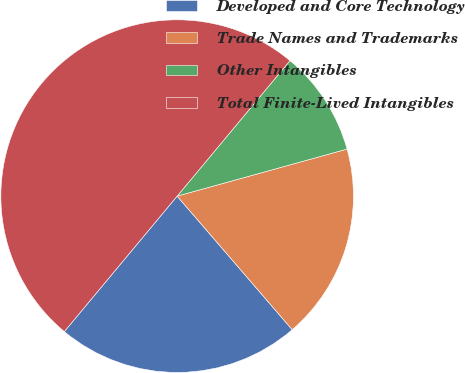Convert chart to OTSL. <chart><loc_0><loc_0><loc_500><loc_500><pie_chart><fcel>Developed and Core Technology<fcel>Trade Names and Trademarks<fcel>Other Intangibles<fcel>Total Finite-Lived Intangibles<nl><fcel>22.37%<fcel>17.98%<fcel>9.65%<fcel>50.0%<nl></chart> 